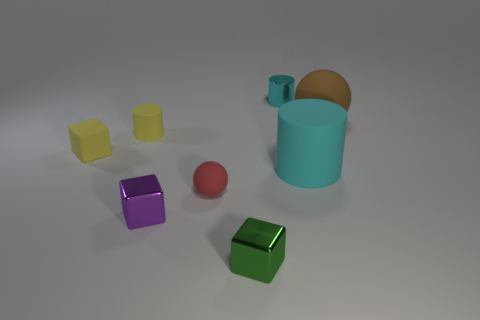Add 1 tiny purple metallic cylinders. How many objects exist? 9 Subtract all spheres. How many objects are left? 6 Subtract 0 brown cylinders. How many objects are left? 8 Subtract all tiny purple blocks. Subtract all large blue shiny things. How many objects are left? 7 Add 6 purple metal cubes. How many purple metal cubes are left? 7 Add 3 small red blocks. How many small red blocks exist? 3 